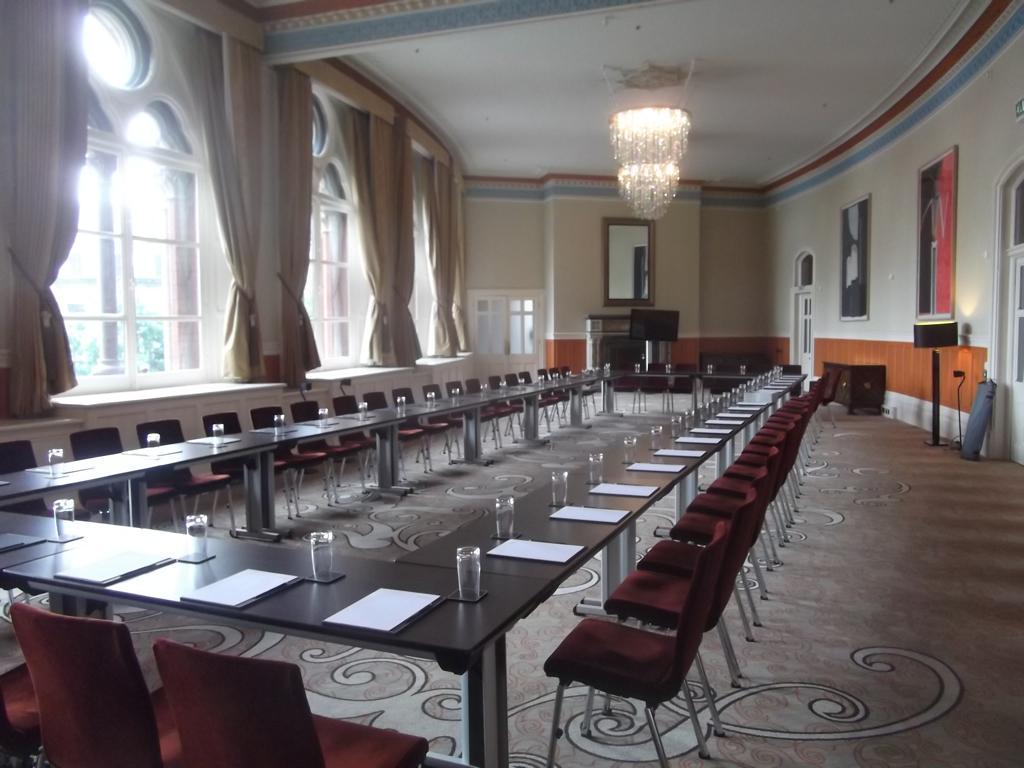How would you summarize this image in a sentence or two? In this image I can see few chairs. I can see few glasses, papers and few objects on the tables. I can see few windows, curtains, doors, few frames and mirror is attached to the wall. I can see few objects on the floor. At the top I can see lights. 